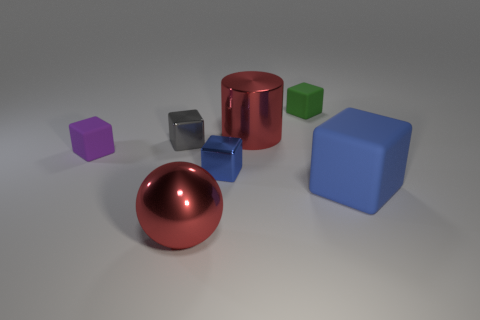What number of large objects are on the left side of the object behind the big red metal thing behind the large matte thing?
Offer a very short reply. 2. The tiny metallic cube on the right side of the tiny gray thing is what color?
Give a very brief answer. Blue. There is a big thing left of the tiny blue object; is it the same color as the large metallic cylinder?
Make the answer very short. Yes. There is a blue rubber object that is the same shape as the green object; what is its size?
Provide a short and direct response. Large. Are there any other things that have the same size as the red sphere?
Offer a very short reply. Yes. There is a big red object on the right side of the large red thing in front of the big red thing behind the small purple rubber cube; what is it made of?
Your answer should be compact. Metal. Are there more big shiny objects that are behind the big block than small purple things that are behind the shiny cylinder?
Your answer should be very brief. Yes. Do the cylinder and the green block have the same size?
Provide a short and direct response. No. There is a large rubber thing that is the same shape as the tiny green matte thing; what is its color?
Your answer should be compact. Blue. What number of big objects have the same color as the large sphere?
Make the answer very short. 1. 